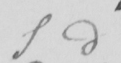Can you tell me what this handwritten text says? S d 